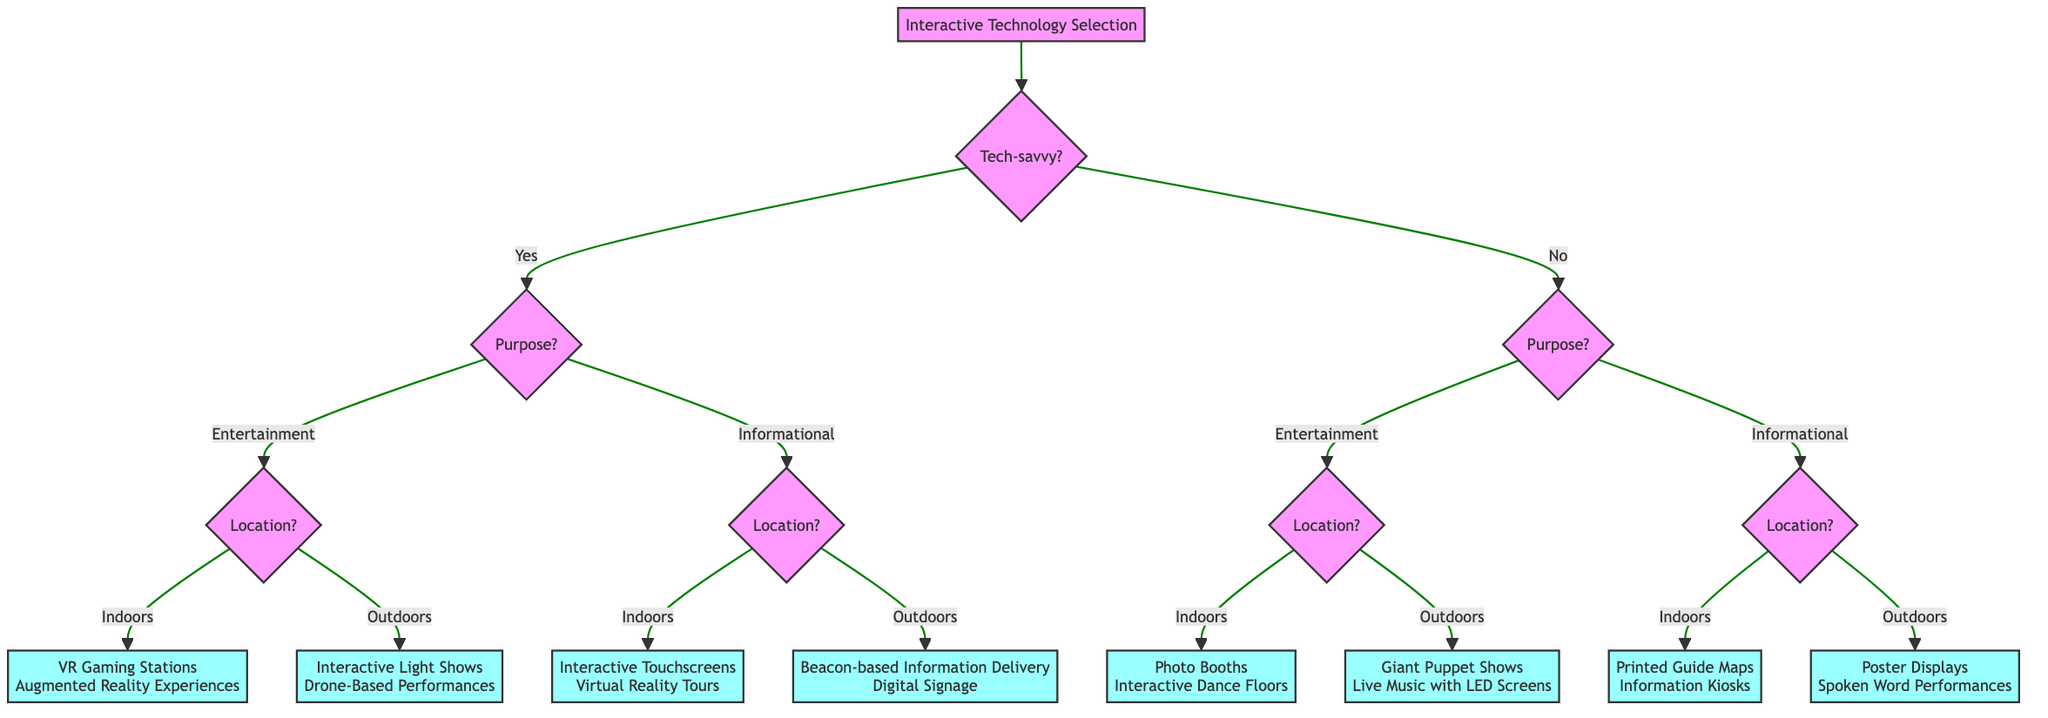What is the first question asked in the decision tree? The diagram starts by asking if the target audience is tech-savvy, which indicates the flow of the decision-making process.
Answer: Is the target audience tech-savvy? How many options are there for the "purpose" node? In the flowchart, the "purpose" node has two options: Entertainment and Informational, leading to further questions based on these choices.
Answer: 2 What are the interactive technologies suggested for tech-savvy audiences in entertainment zones indoors? Upon following the tree for tech-savvy, entertainment, and indoors, the suggested technologies are VR Gaming Stations and Augmented Reality Experiences.
Answer: VR Gaming Stations, Augmented Reality Experiences Which options are presented for non-tech-savvy audiences in informational zones outdoors? Following the path for non-tech-savvy, informational, and outdoors, the options are Beacon-based Information Delivery and Digital Signage, representing technologies suited for this context.
Answer: Beacon-based Information Delivery, Digital Signage If the target audience is not tech-savvy and the zone is outdoors for entertainment, what technologies are proposed? The flow indicates that non-tech-savvy audiences in outdoor entertainment zones lead to the selection of Giant Puppet Shows and Live Music Performances with LED Screens.
Answer: Giant Puppet Shows, Live Music Performances with LED Screens What is the last decision point in the decision tree? The final decision points are the options provided based on indoor or outdoor environments for both tech-savvy and non-tech-savvy audiences, depending on their purpose.
Answer: Indoors or Outdoors for each audience type What technology is recommended for tech-savvy, informational zones indoors? The diagram specifies that tech-savvy audiences in indoor informational zones should use Interactive Touchscreens and Virtual Reality Tours.
Answer: Interactive Touchscreens, Virtual Reality Tours How many total distinct outputs are there in the decision tree? The total outputs are derived from the outcomes of each path in the decision tree, which results in eight distinct technology recommendations across various audience types and zones.
Answer: 8 